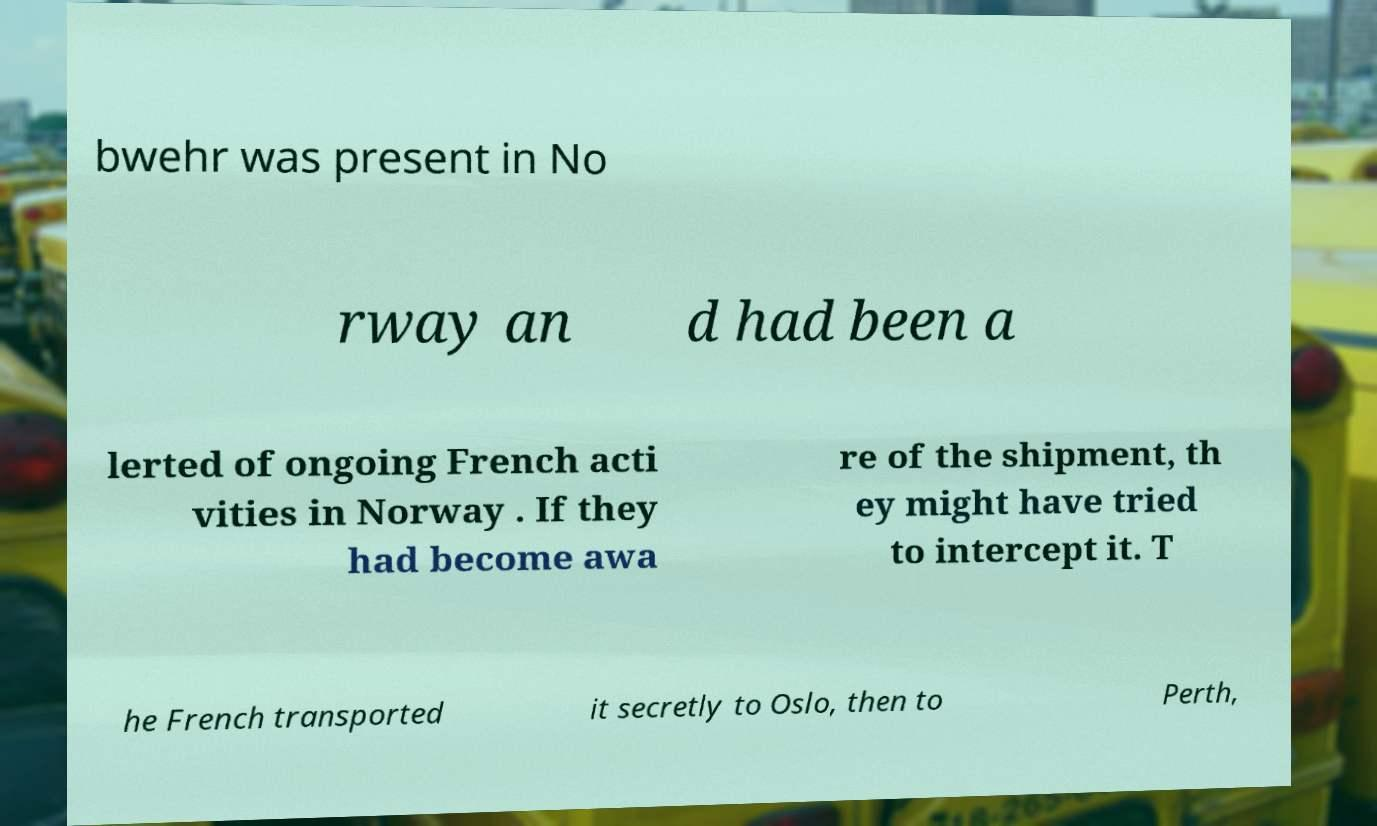Please read and relay the text visible in this image. What does it say? bwehr was present in No rway an d had been a lerted of ongoing French acti vities in Norway . If they had become awa re of the shipment, th ey might have tried to intercept it. T he French transported it secretly to Oslo, then to Perth, 